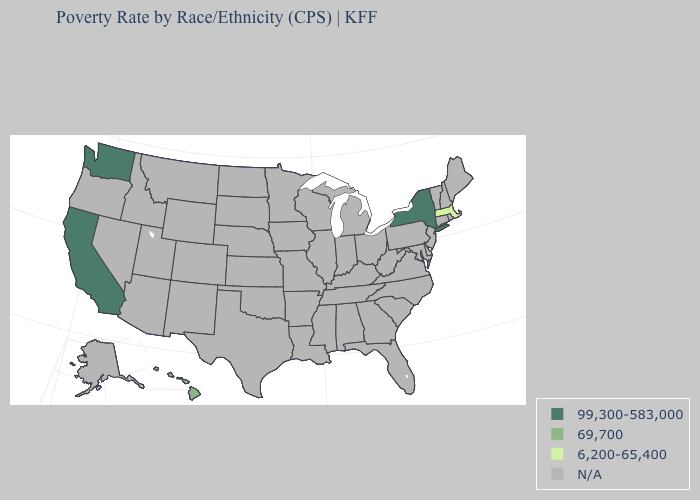What is the value of Arizona?
Keep it brief. N/A. Name the states that have a value in the range 99,300-583,000?
Concise answer only. California, New York, Washington. Name the states that have a value in the range 6,200-65,400?
Answer briefly. Massachusetts. Does Hawaii have the lowest value in the USA?
Short answer required. No. Does New York have the highest value in the USA?
Quick response, please. Yes. What is the value of Oregon?
Short answer required. N/A. What is the value of Maryland?
Keep it brief. N/A. Name the states that have a value in the range 99,300-583,000?
Short answer required. California, New York, Washington. Does Hawaii have the highest value in the USA?
Answer briefly. No. Name the states that have a value in the range N/A?
Quick response, please. Alabama, Alaska, Arizona, Arkansas, Colorado, Connecticut, Delaware, Florida, Georgia, Idaho, Illinois, Indiana, Iowa, Kansas, Kentucky, Louisiana, Maine, Maryland, Michigan, Minnesota, Mississippi, Missouri, Montana, Nebraska, Nevada, New Hampshire, New Jersey, New Mexico, North Carolina, North Dakota, Ohio, Oklahoma, Oregon, Pennsylvania, Rhode Island, South Carolina, South Dakota, Tennessee, Texas, Utah, Vermont, Virginia, West Virginia, Wisconsin, Wyoming. What is the lowest value in the USA?
Concise answer only. 6,200-65,400. Name the states that have a value in the range N/A?
Answer briefly. Alabama, Alaska, Arizona, Arkansas, Colorado, Connecticut, Delaware, Florida, Georgia, Idaho, Illinois, Indiana, Iowa, Kansas, Kentucky, Louisiana, Maine, Maryland, Michigan, Minnesota, Mississippi, Missouri, Montana, Nebraska, Nevada, New Hampshire, New Jersey, New Mexico, North Carolina, North Dakota, Ohio, Oklahoma, Oregon, Pennsylvania, Rhode Island, South Carolina, South Dakota, Tennessee, Texas, Utah, Vermont, Virginia, West Virginia, Wisconsin, Wyoming. Does New York have the highest value in the Northeast?
Concise answer only. Yes. 